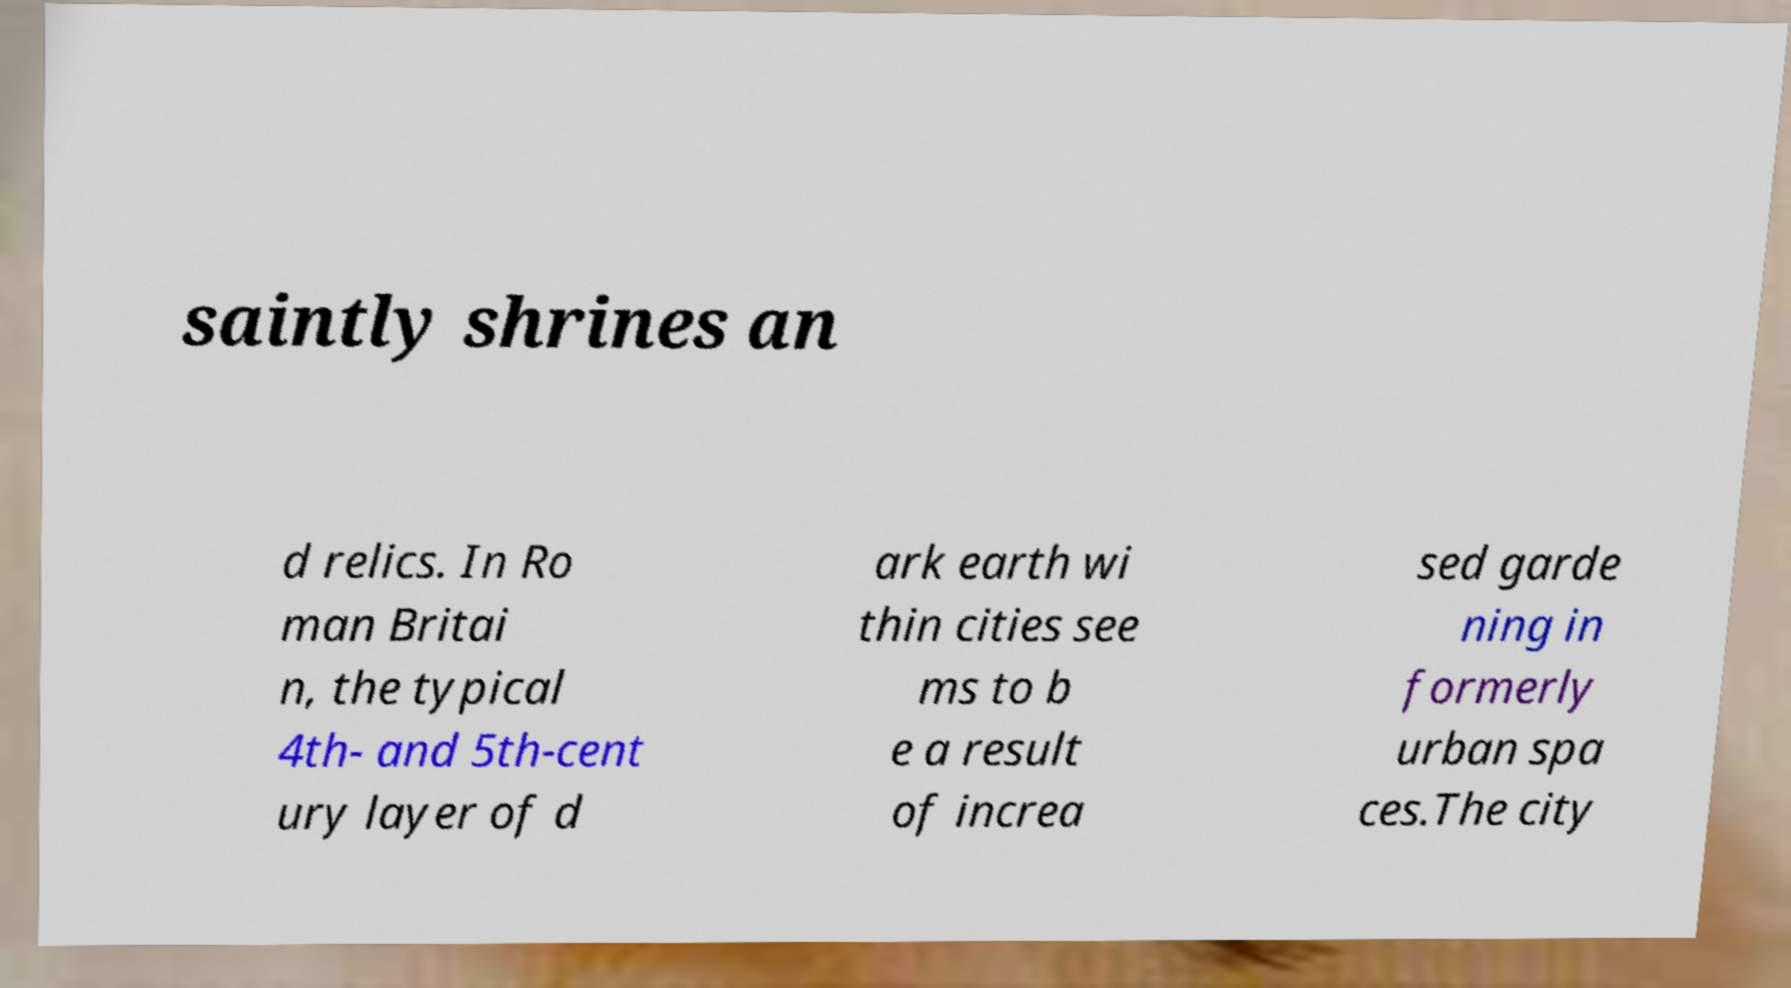Please read and relay the text visible in this image. What does it say? saintly shrines an d relics. In Ro man Britai n, the typical 4th- and 5th-cent ury layer of d ark earth wi thin cities see ms to b e a result of increa sed garde ning in formerly urban spa ces.The city 